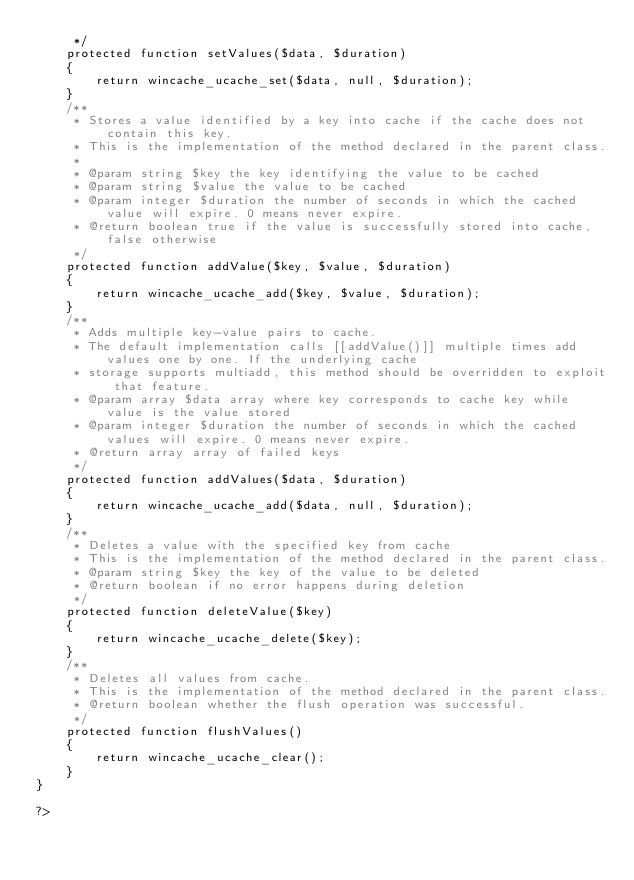<code> <loc_0><loc_0><loc_500><loc_500><_PHP_>     */
    protected function setValues($data, $duration)
    {
        return wincache_ucache_set($data, null, $duration);
    }
    /**
     * Stores a value identified by a key into cache if the cache does not contain this key.
     * This is the implementation of the method declared in the parent class.
     *
     * @param string $key the key identifying the value to be cached
     * @param string $value the value to be cached
     * @param integer $duration the number of seconds in which the cached value will expire. 0 means never expire.
     * @return boolean true if the value is successfully stored into cache, false otherwise
     */
    protected function addValue($key, $value, $duration)
    {
        return wincache_ucache_add($key, $value, $duration);
    }
    /**
     * Adds multiple key-value pairs to cache.
     * The default implementation calls [[addValue()]] multiple times add values one by one. If the underlying cache
     * storage supports multiadd, this method should be overridden to exploit that feature.
     * @param array $data array where key corresponds to cache key while value is the value stored
     * @param integer $duration the number of seconds in which the cached values will expire. 0 means never expire.
     * @return array array of failed keys
     */
    protected function addValues($data, $duration)
    {
        return wincache_ucache_add($data, null, $duration);
    }
    /**
     * Deletes a value with the specified key from cache
     * This is the implementation of the method declared in the parent class.
     * @param string $key the key of the value to be deleted
     * @return boolean if no error happens during deletion
     */
    protected function deleteValue($key)
    {
        return wincache_ucache_delete($key);
    }
    /**
     * Deletes all values from cache.
     * This is the implementation of the method declared in the parent class.
     * @return boolean whether the flush operation was successful.
     */
    protected function flushValues()
    {
        return wincache_ucache_clear();
    }
}

?></code> 